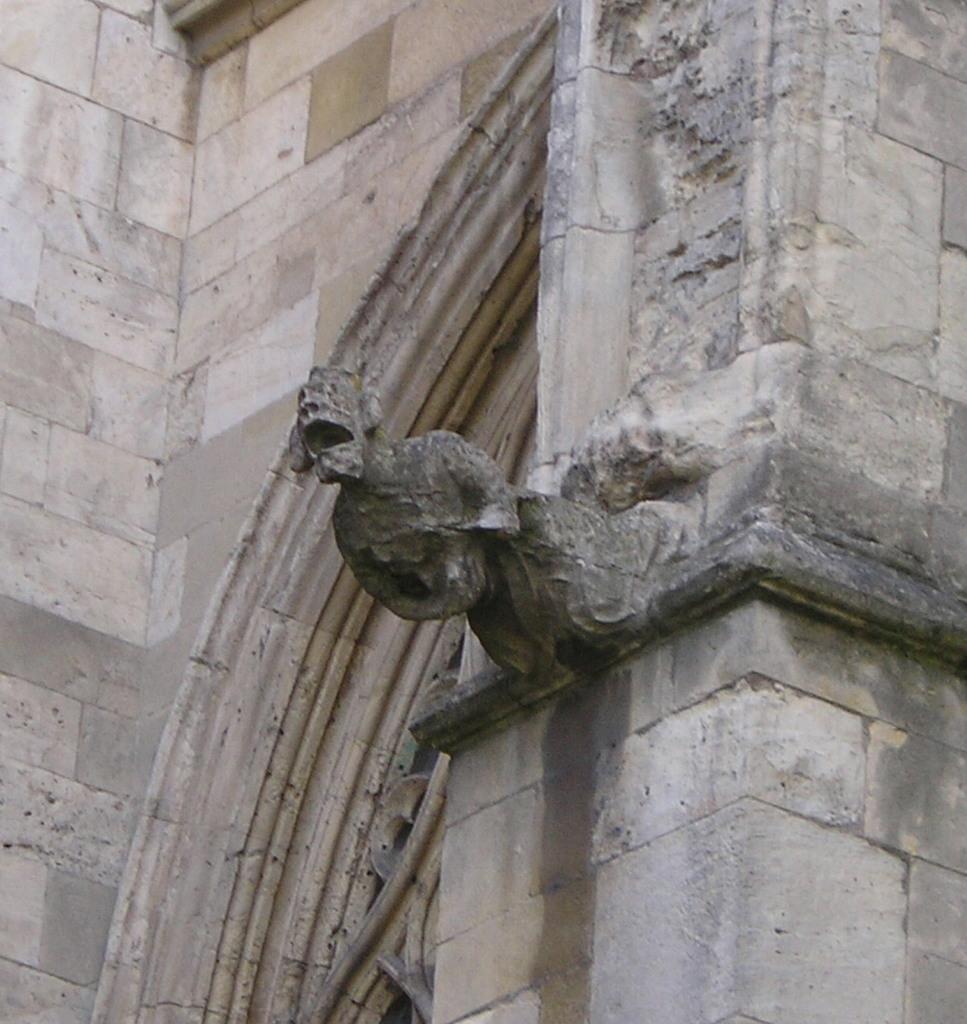In one or two sentences, can you explain what this image depicts? In this image I can see in the middle there is a statue and it looks like a construction. 